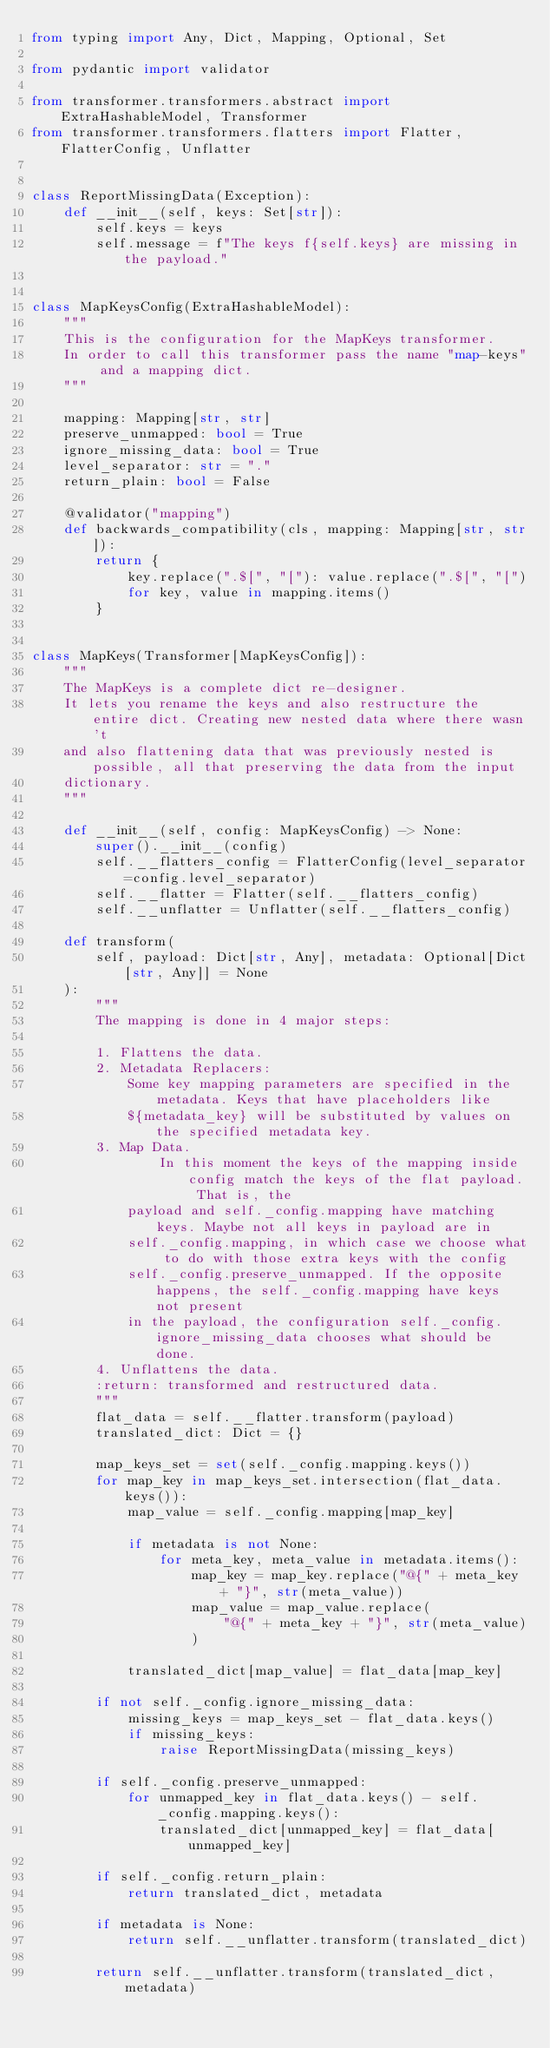<code> <loc_0><loc_0><loc_500><loc_500><_Python_>from typing import Any, Dict, Mapping, Optional, Set

from pydantic import validator

from transformer.transformers.abstract import ExtraHashableModel, Transformer
from transformer.transformers.flatters import Flatter, FlatterConfig, Unflatter


class ReportMissingData(Exception):
    def __init__(self, keys: Set[str]):
        self.keys = keys
        self.message = f"The keys f{self.keys} are missing in the payload."


class MapKeysConfig(ExtraHashableModel):
    """
    This is the configuration for the MapKeys transformer.
    In order to call this transformer pass the name "map-keys" and a mapping dict.
    """

    mapping: Mapping[str, str]
    preserve_unmapped: bool = True
    ignore_missing_data: bool = True
    level_separator: str = "."
    return_plain: bool = False

    @validator("mapping")
    def backwards_compatibility(cls, mapping: Mapping[str, str]):
        return {
            key.replace(".$[", "["): value.replace(".$[", "[")
            for key, value in mapping.items()
        }


class MapKeys(Transformer[MapKeysConfig]):
    """
    The MapKeys is a complete dict re-designer.
    It lets you rename the keys and also restructure the entire dict. Creating new nested data where there wasn't
    and also flattening data that was previously nested is possible, all that preserving the data from the input
    dictionary.
    """

    def __init__(self, config: MapKeysConfig) -> None:
        super().__init__(config)
        self.__flatters_config = FlatterConfig(level_separator=config.level_separator)
        self.__flatter = Flatter(self.__flatters_config)
        self.__unflatter = Unflatter(self.__flatters_config)

    def transform(
        self, payload: Dict[str, Any], metadata: Optional[Dict[str, Any]] = None
    ):
        """
        The mapping is done in 4 major steps:

        1. Flattens the data.
        2. Metadata Replacers:
            Some key mapping parameters are specified in the metadata. Keys that have placeholders like
            ${metadata_key} will be substituted by values on the specified metadata key.
        3. Map Data.
                In this moment the keys of the mapping inside config match the keys of the flat payload. That is, the
            payload and self._config.mapping have matching keys. Maybe not all keys in payload are in
            self._config.mapping, in which case we choose what to do with those extra keys with the config
            self._config.preserve_unmapped. If the opposite happens, the self._config.mapping have keys not present
            in the payload, the configuration self._config.ignore_missing_data chooses what should be done.
        4. Unflattens the data.
        :return: transformed and restructured data.
        """
        flat_data = self.__flatter.transform(payload)
        translated_dict: Dict = {}

        map_keys_set = set(self._config.mapping.keys())
        for map_key in map_keys_set.intersection(flat_data.keys()):
            map_value = self._config.mapping[map_key]

            if metadata is not None:
                for meta_key, meta_value in metadata.items():
                    map_key = map_key.replace("@{" + meta_key + "}", str(meta_value))
                    map_value = map_value.replace(
                        "@{" + meta_key + "}", str(meta_value)
                    )

            translated_dict[map_value] = flat_data[map_key]

        if not self._config.ignore_missing_data:
            missing_keys = map_keys_set - flat_data.keys()
            if missing_keys:
                raise ReportMissingData(missing_keys)

        if self._config.preserve_unmapped:
            for unmapped_key in flat_data.keys() - self._config.mapping.keys():
                translated_dict[unmapped_key] = flat_data[unmapped_key]

        if self._config.return_plain:
            return translated_dict, metadata

        if metadata is None:
            return self.__unflatter.transform(translated_dict)

        return self.__unflatter.transform(translated_dict, metadata)
</code> 